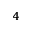Convert formula to latex. <formula><loc_0><loc_0><loc_500><loc_500>_ { 4 }</formula> 